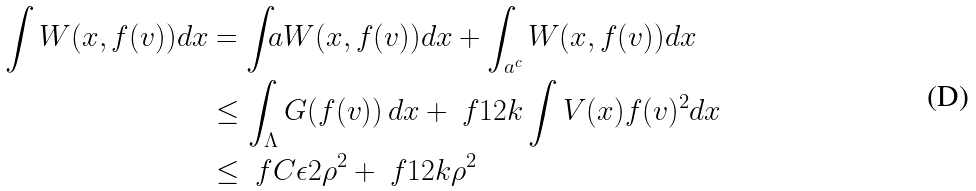<formula> <loc_0><loc_0><loc_500><loc_500>\int W ( x , f ( v ) ) d x & = \int _ { \L } a W ( x , f ( v ) ) d x + \int _ { \L a ^ { c } } W ( x , f ( v ) ) d x \\ & \leq \int _ { \Lambda } G ( f ( v ) ) \, d x + \ f { 1 } { 2 k } \int V ( x ) f ( v ) ^ { 2 } d x \\ & \leq \ f { C \epsilon } { 2 } \rho ^ { 2 } + \ f { 1 } { 2 k } \rho ^ { 2 }</formula> 